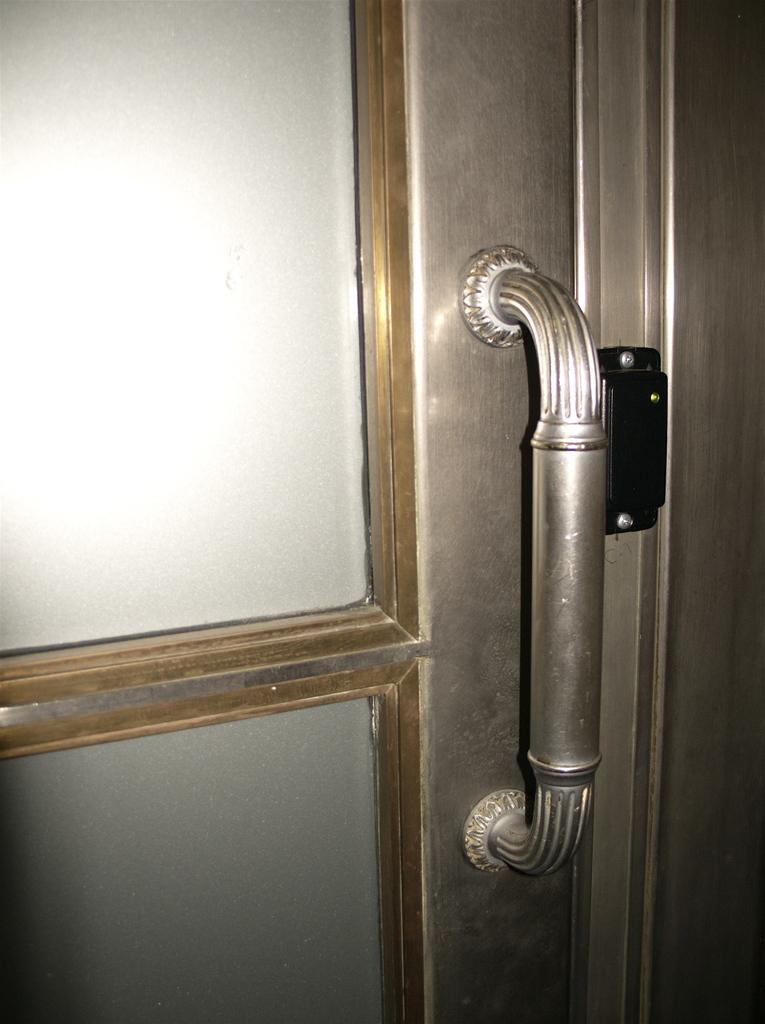What is a prominent feature in the image? There is a door in the image. What part of the door can be used to open or close it? The door has a handle. Can you describe the color of any object in the image? There is a black colored object in the image. What type of animal is making bubbles in the image? There are no animals or bubbles present in the image. 